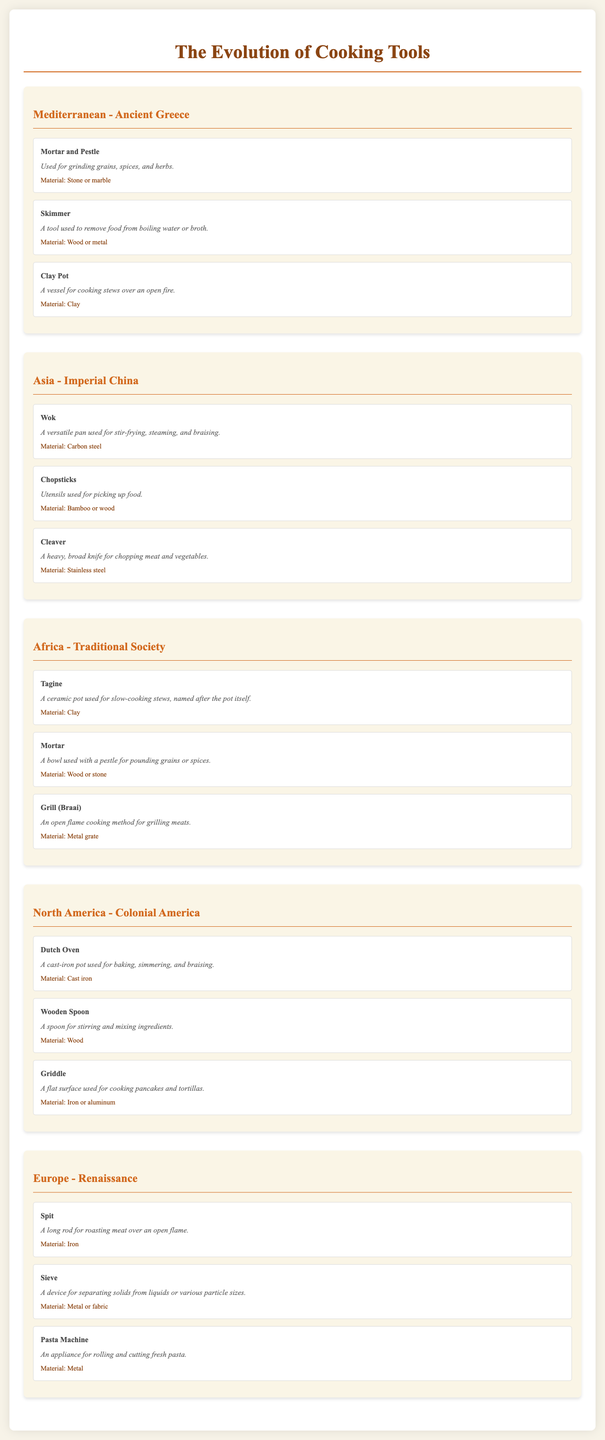What tool is used for grinding grains? The document states that the "Mortar and Pestle" is used for grinding grains, spices, and herbs in Ancient Greece.
Answer: Mortar and Pestle What material is the Wok made of? The document specifies that the Wok is made of "Carbon steel" in Imperial China.
Answer: Carbon steel Which region's cooking tool is the Tagine? According to the document, the Tagine is categorized under "Africa - Traditional Society."
Answer: Africa - Traditional Society How many tools are listed under Colonial America? The document indicates that there are three tools listed under "North America - Colonial America."
Answer: 3 What function does a Sieve perform? The document describes a Sieve as a device for separating solids from liquids or various particle sizes.
Answer: Separating solids from liquids Which cooking tool is described as a ceramic pot for slow-cooking stews? The document refers to the Tagine as a ceramic pot used for slow-cooking stews.
Answer: Tagine What is the primary use of the Dutch Oven? The document states that the Dutch Oven is used for baking, simmering, and braising.
Answer: Baking, simmering, and braising What is the tool material used in the Sieve? According to the document, the Sieve is made of "Metal or fabric."
Answer: Metal or fabric What is the historical era associated with the Pasta Machine? The document notes that the Pasta Machine is related to the "Renaissance" era in Europe.
Answer: Renaissance 